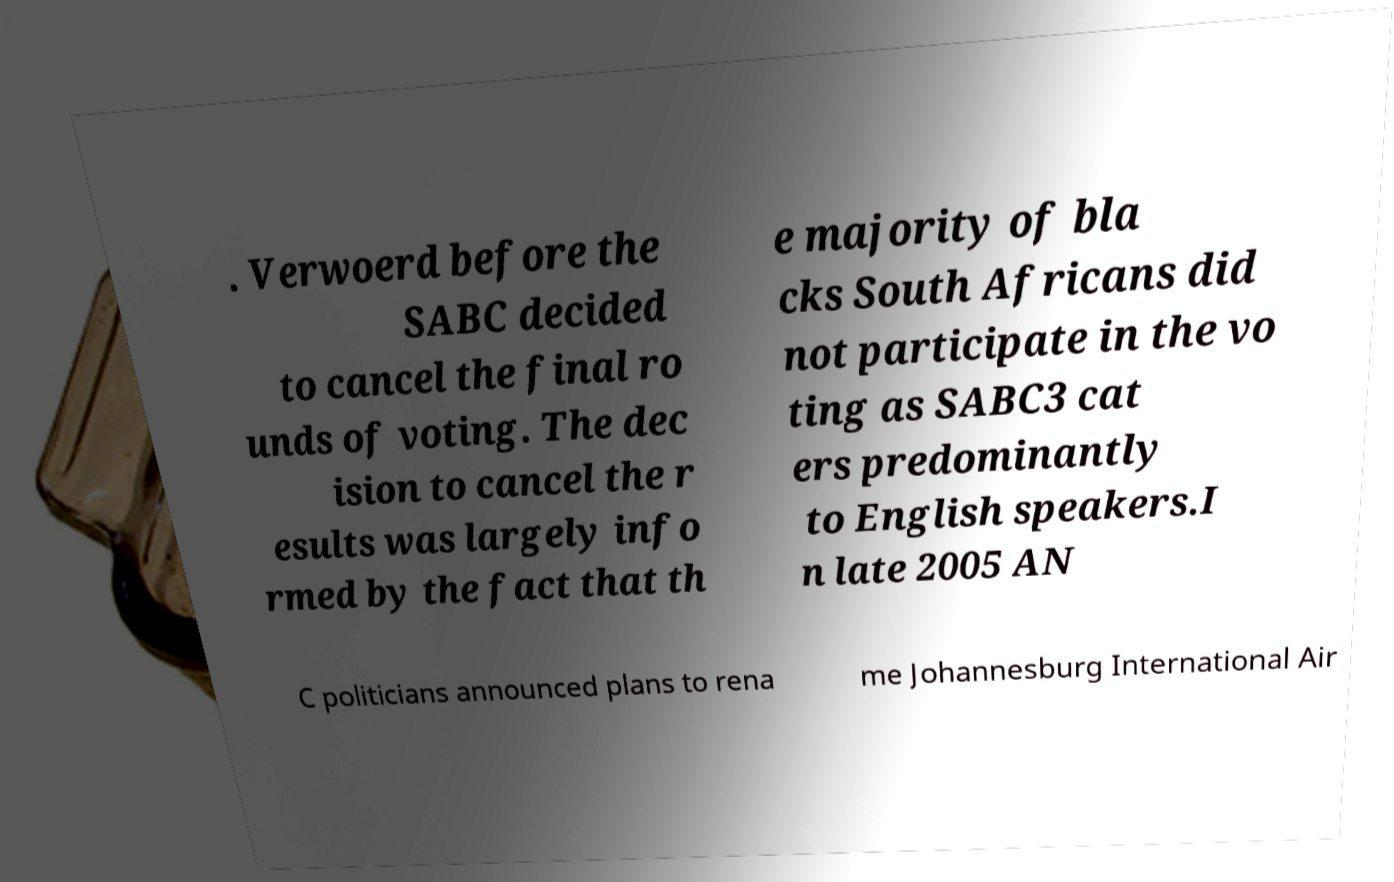Could you extract and type out the text from this image? . Verwoerd before the SABC decided to cancel the final ro unds of voting. The dec ision to cancel the r esults was largely info rmed by the fact that th e majority of bla cks South Africans did not participate in the vo ting as SABC3 cat ers predominantly to English speakers.I n late 2005 AN C politicians announced plans to rena me Johannesburg International Air 